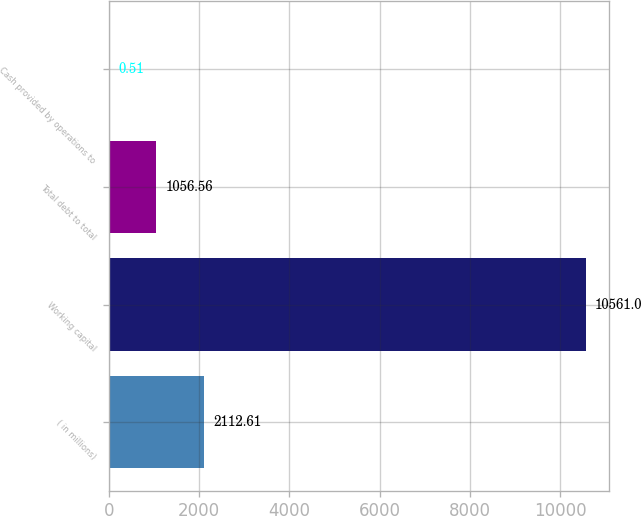Convert chart. <chart><loc_0><loc_0><loc_500><loc_500><bar_chart><fcel>( in millions)<fcel>Working capital<fcel>Total debt to total<fcel>Cash provided by operations to<nl><fcel>2112.61<fcel>10561<fcel>1056.56<fcel>0.51<nl></chart> 